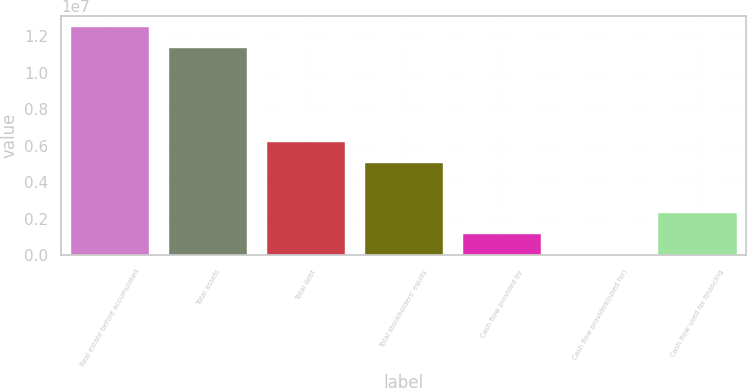Convert chart. <chart><loc_0><loc_0><loc_500><loc_500><bar_chart><fcel>Real estate before accumulated<fcel>Total assets<fcel>Total debt<fcel>Total stockholders' equity<fcel>Cash flow provided by<fcel>Cash flow provided/(used for)<fcel>Cash flow used for financing<nl><fcel>1.24989e+07<fcel>1.13442e+07<fcel>6.20104e+06<fcel>5.0463e+06<fcel>1.17611e+06<fcel>21365<fcel>2.33085e+06<nl></chart> 